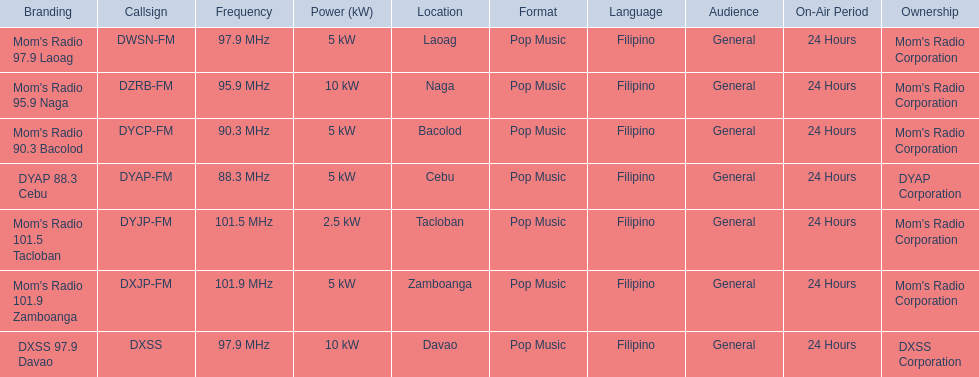Which stations use less than 10kw of power? Mom's Radio 97.9 Laoag, Mom's Radio 90.3 Bacolod, DYAP 88.3 Cebu, Mom's Radio 101.5 Tacloban, Mom's Radio 101.9 Zamboanga. Do any stations use less than 5kw of power? if so, which ones? Mom's Radio 101.5 Tacloban. 